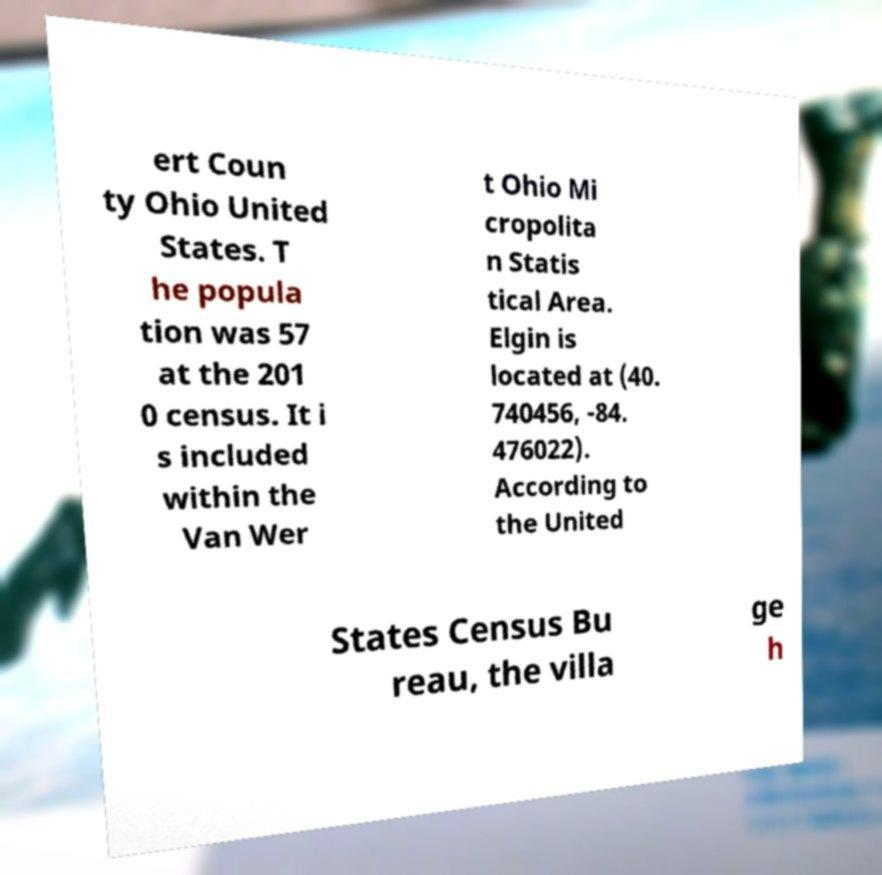Could you assist in decoding the text presented in this image and type it out clearly? ert Coun ty Ohio United States. T he popula tion was 57 at the 201 0 census. It i s included within the Van Wer t Ohio Mi cropolita n Statis tical Area. Elgin is located at (40. 740456, -84. 476022). According to the United States Census Bu reau, the villa ge h 